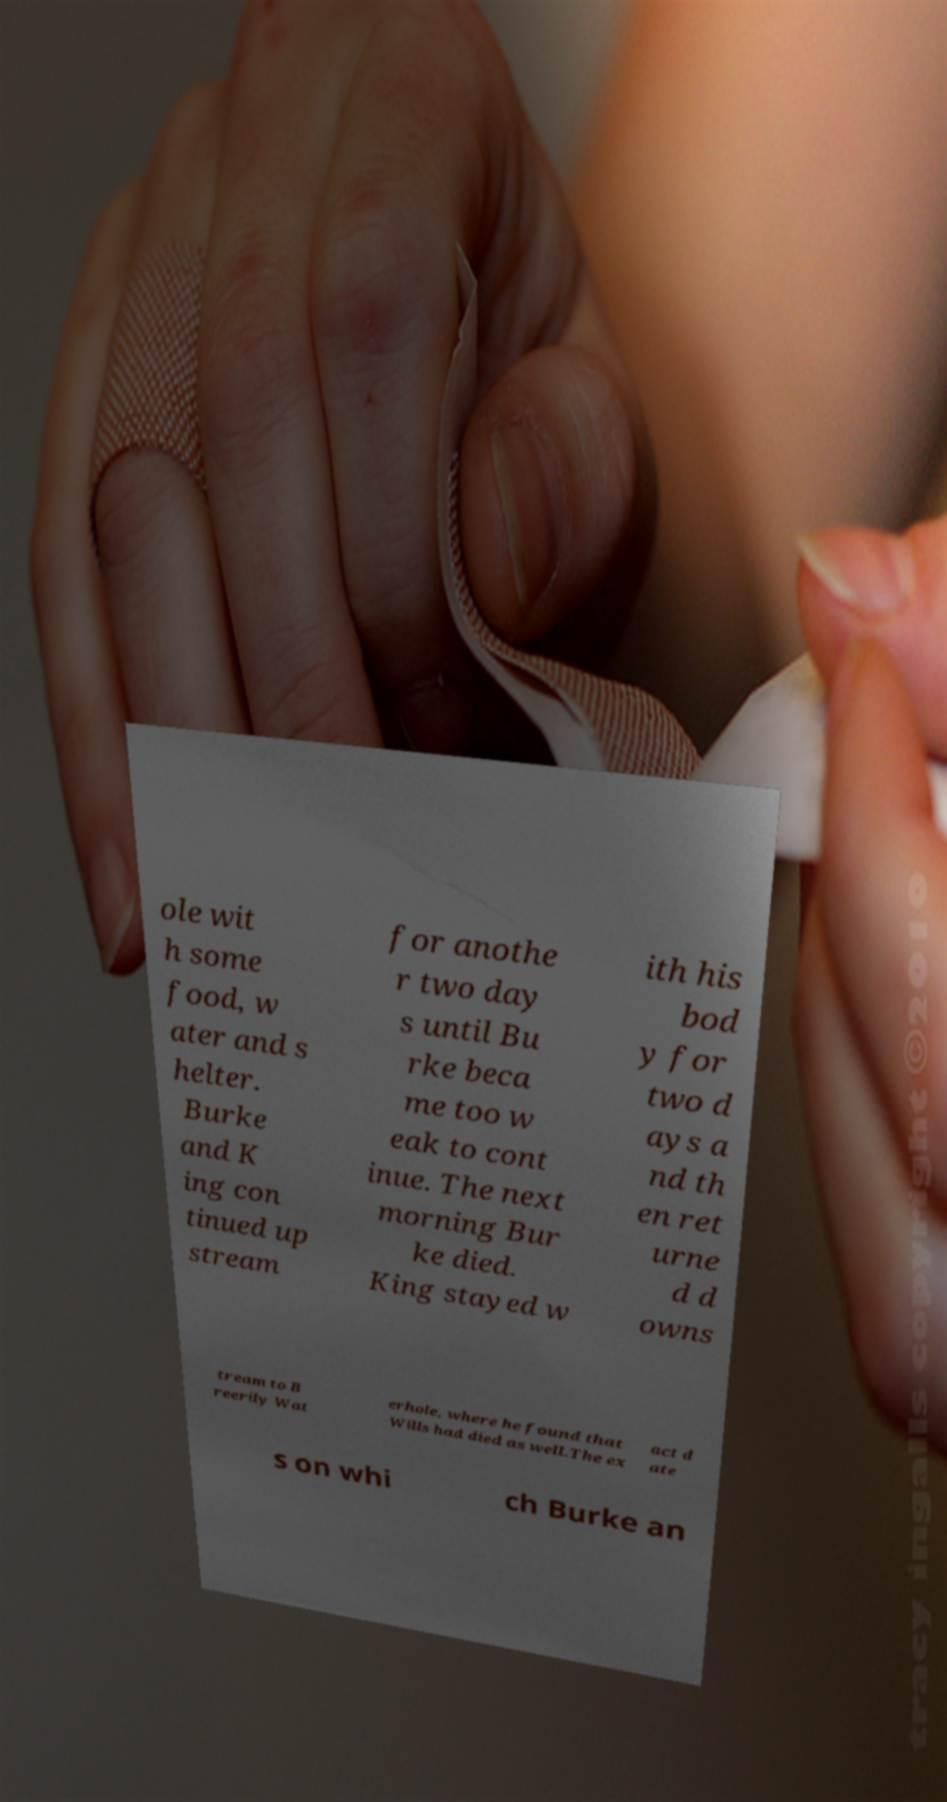What messages or text are displayed in this image? I need them in a readable, typed format. ole wit h some food, w ater and s helter. Burke and K ing con tinued up stream for anothe r two day s until Bu rke beca me too w eak to cont inue. The next morning Bur ke died. King stayed w ith his bod y for two d ays a nd th en ret urne d d owns tream to B reerily Wat erhole, where he found that Wills had died as well.The ex act d ate s on whi ch Burke an 